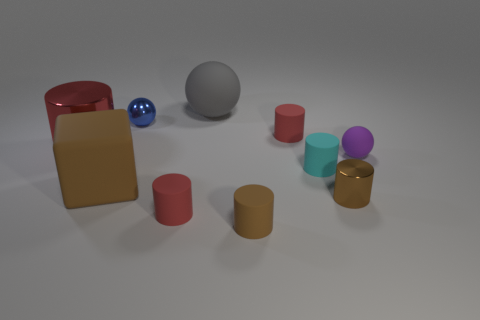Is there a pattern to the arrangement of the objects? There doesn't seem to be a strict pattern to the arrangement of objects, but they are spread in a manner that balances the composition. The objects are spaced in a way that guides the viewer's eye through the scene, creating a sense of intentional placement without rigid symmetry. 